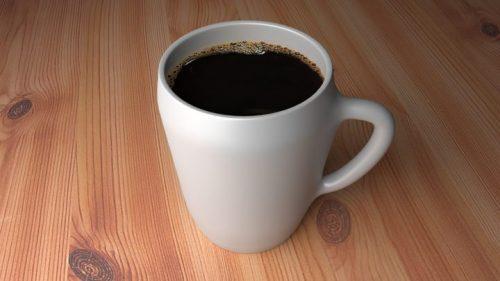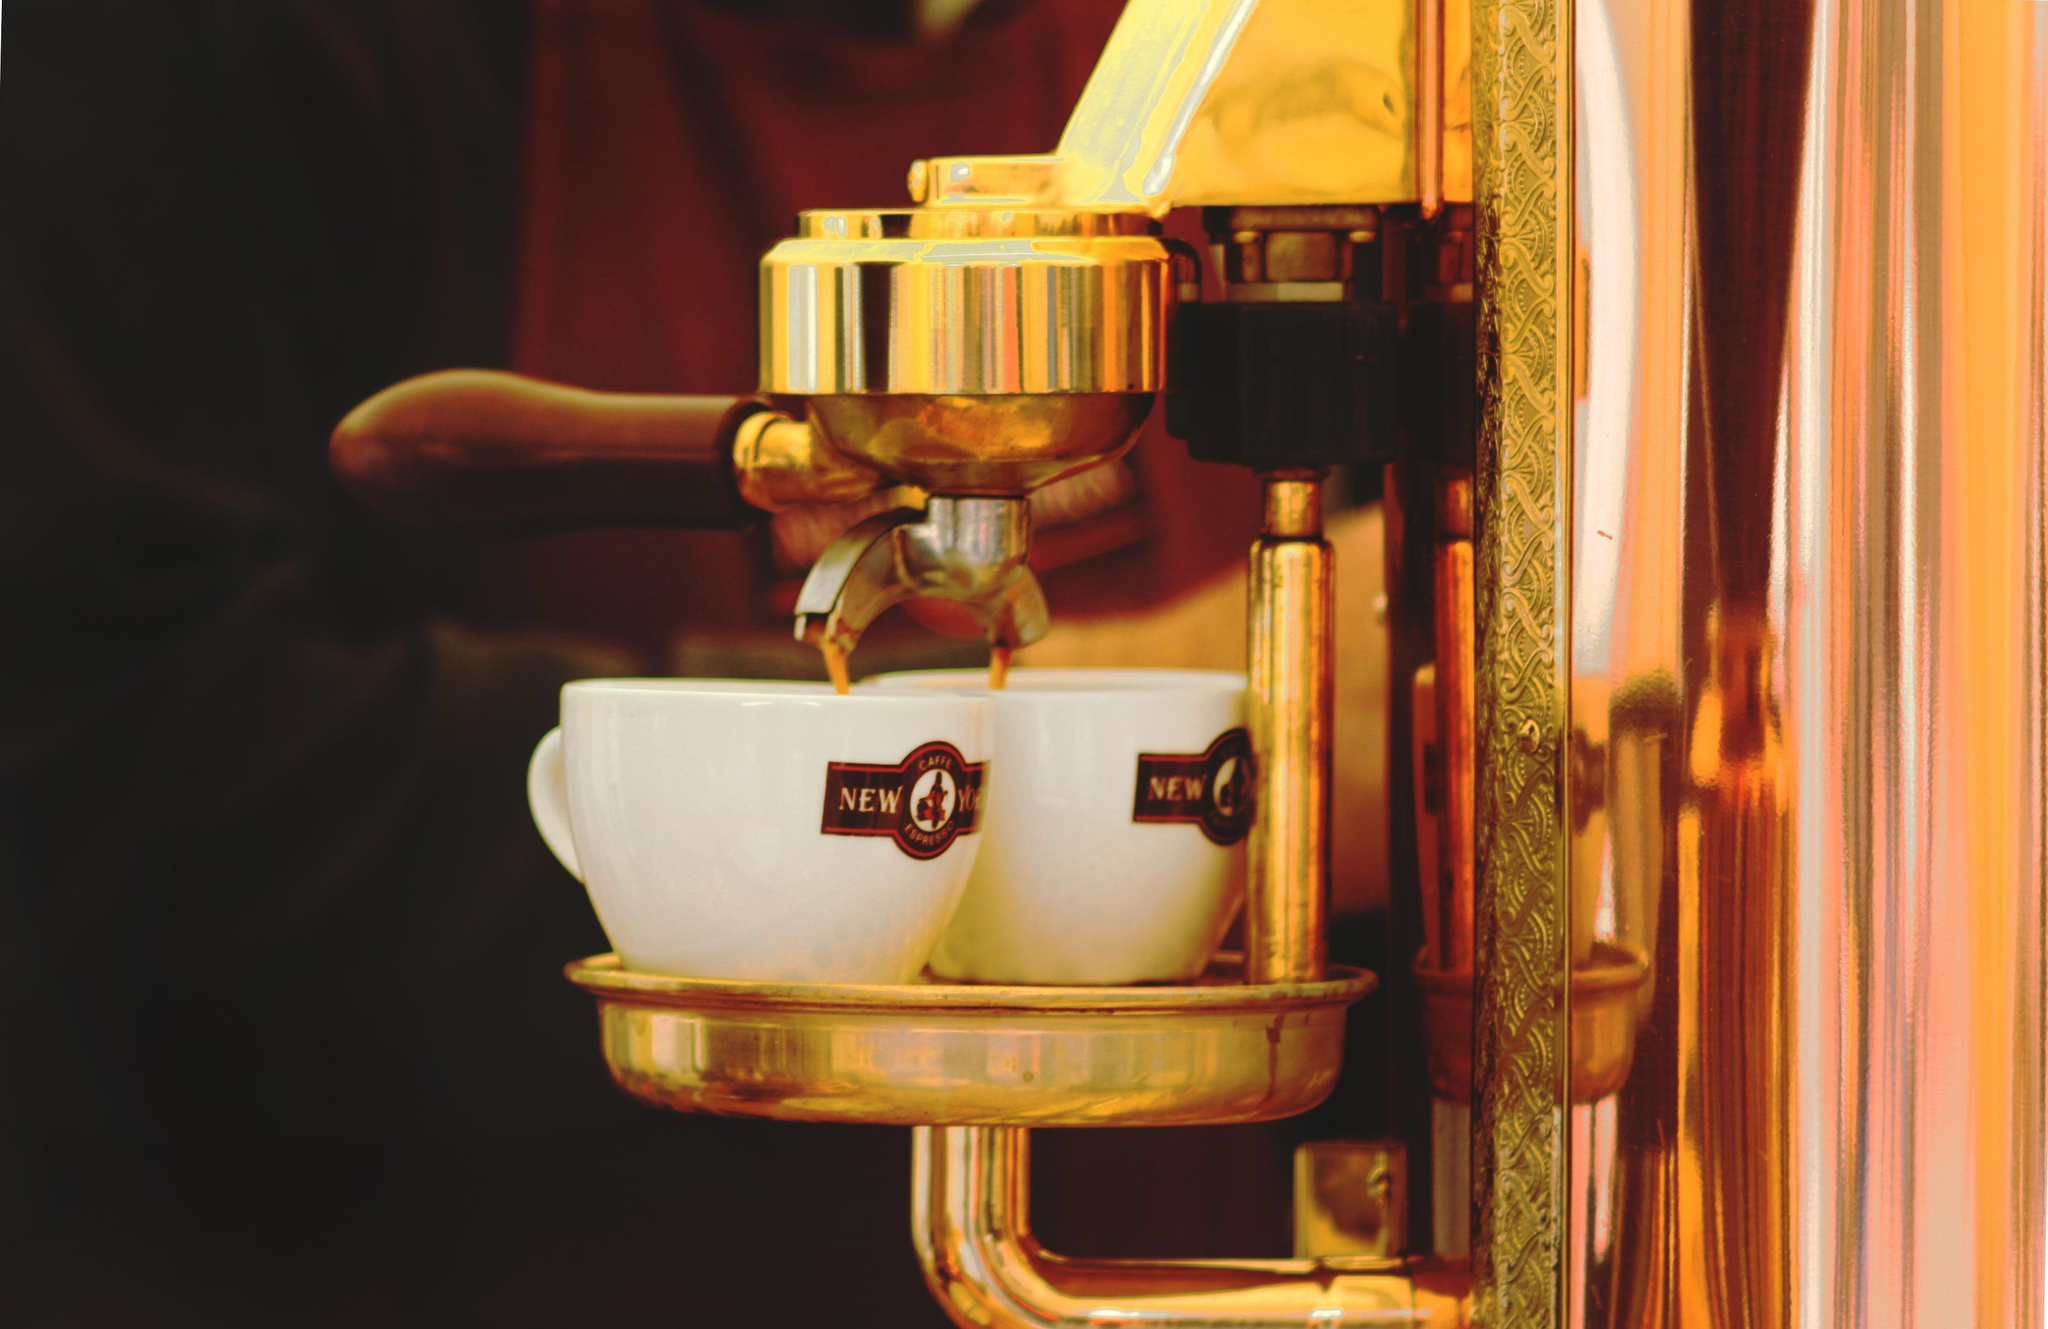The first image is the image on the left, the second image is the image on the right. For the images shown, is this caption "Some cups are made of plastic." true? Answer yes or no. No. 